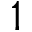Convert formula to latex. <formula><loc_0><loc_0><loc_500><loc_500>1</formula> 